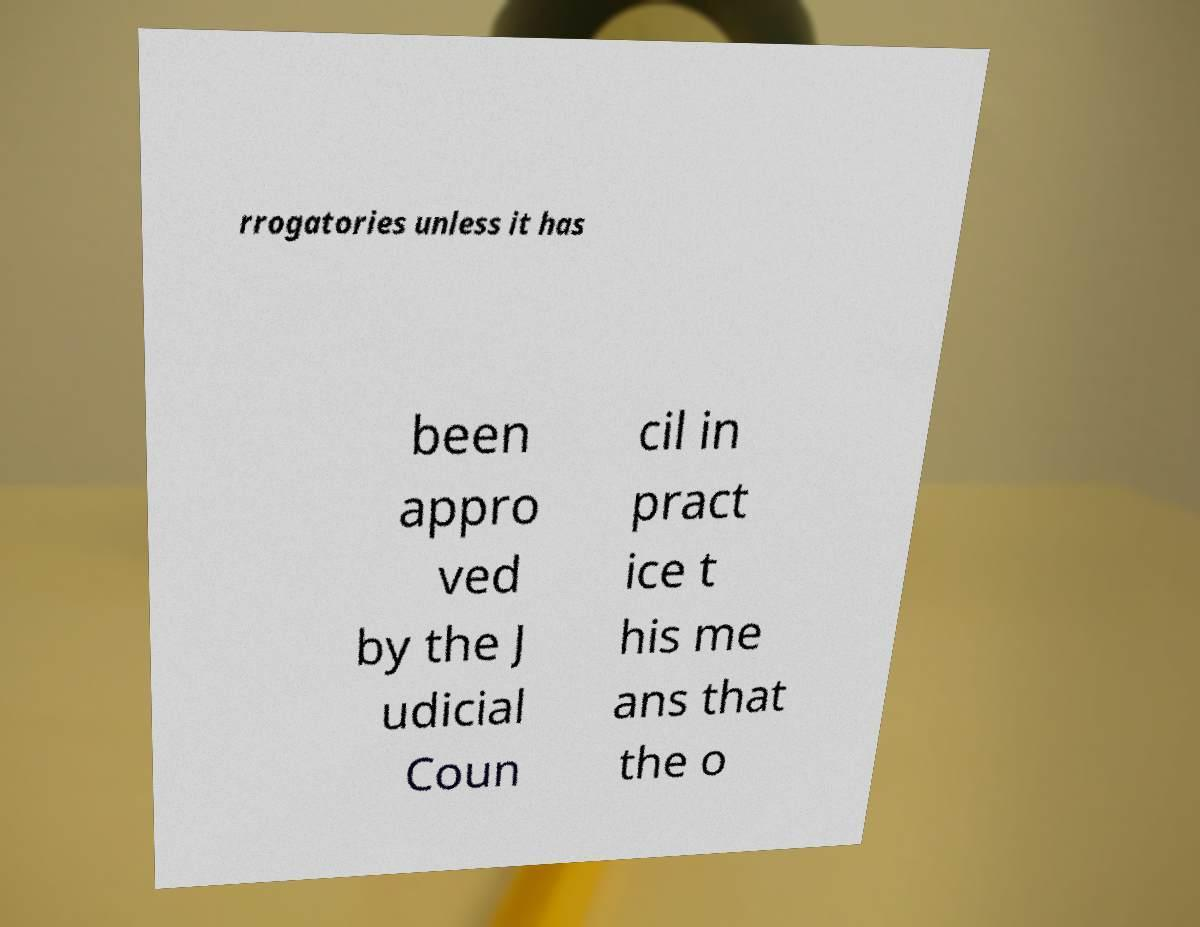Can you accurately transcribe the text from the provided image for me? rrogatories unless it has been appro ved by the J udicial Coun cil in pract ice t his me ans that the o 